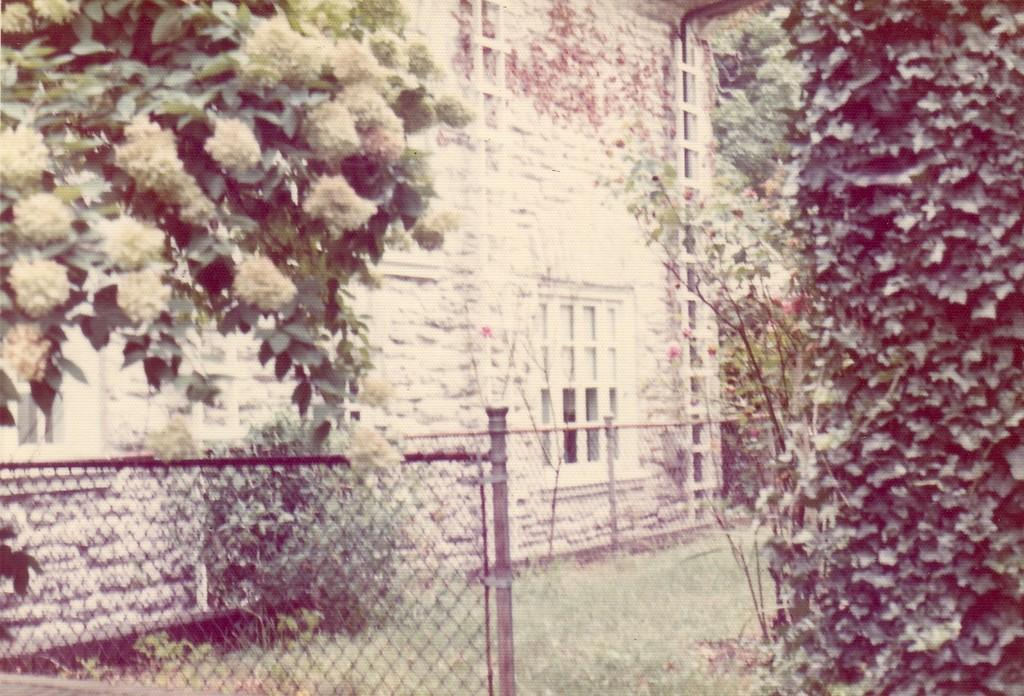What type of structures can be seen in the image? There are buildings in the image. What type of natural elements are present in the image? There are trees and plants in the image. What type of material or design can be seen in the image? There are meshes in the image. What is visible at the bottom of the image? The ground is visible at the bottom of the image. What type of vegetable is being distributed in the image? There is no vegetable or distribution process present in the image. Can you tell me how many volleyballs are visible in the image? There are no volleyballs present in the image. 